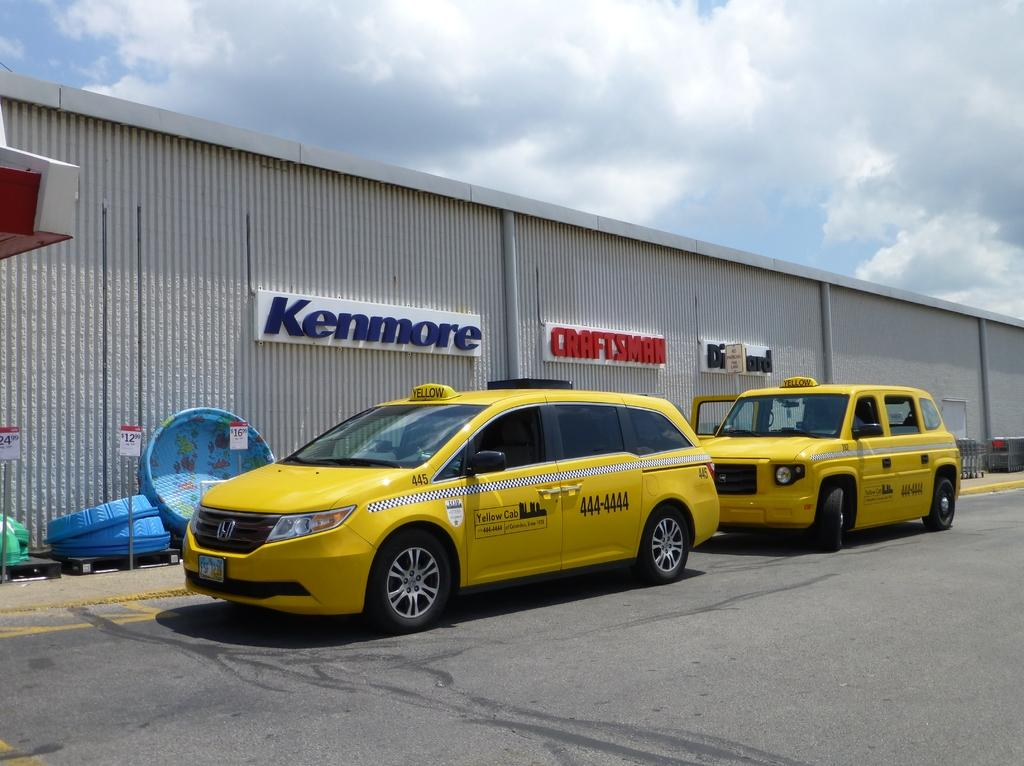Provide a one-sentence caption for the provided image. a building that has a kenmore sign on it. 